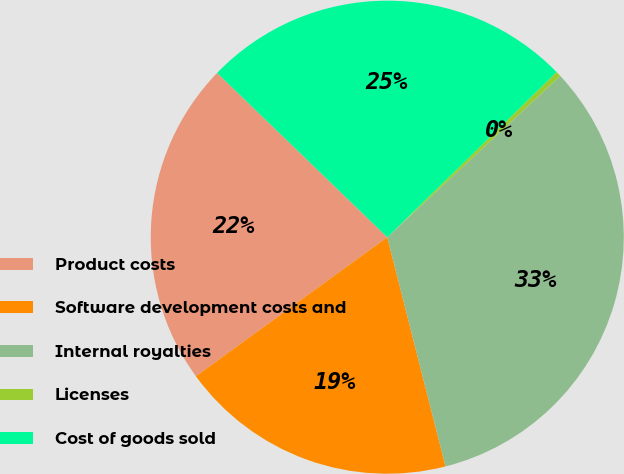<chart> <loc_0><loc_0><loc_500><loc_500><pie_chart><fcel>Product costs<fcel>Software development costs and<fcel>Internal royalties<fcel>Licenses<fcel>Cost of goods sold<nl><fcel>22.22%<fcel>18.96%<fcel>32.98%<fcel>0.36%<fcel>25.48%<nl></chart> 